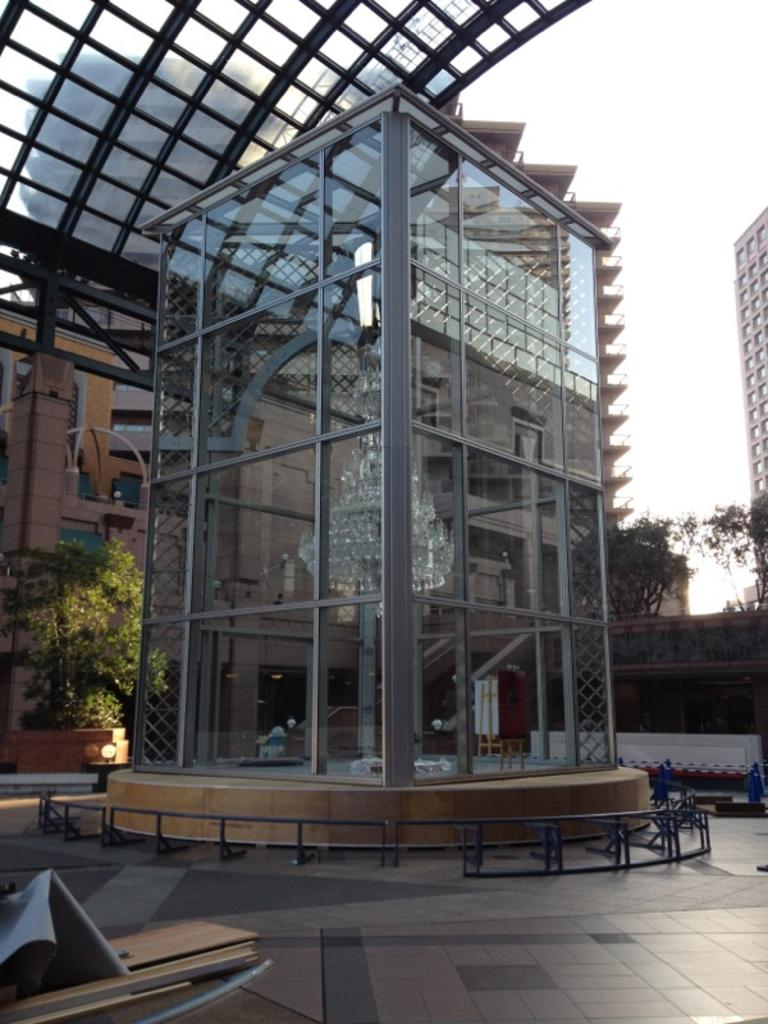What type of structures are visible in the image? There are buildings in the image. Can you describe a specific feature of one of the buildings? There is a chandelier light in one of the buildings. What can be seen in the background of the image? There are trees and metal rods in the background of the image. Are there any other light sources visible in the image? Yes, there are lights in the background of the image. What type of pet can be seen playing with hair in the image? There is no pet or hair present in the image; it features buildings, trees, metal rods, and lights. How does the power affect the chandelier light in the image? The image does not provide information about the power source for the chandelier light, so we cannot determine its effect on the light. 